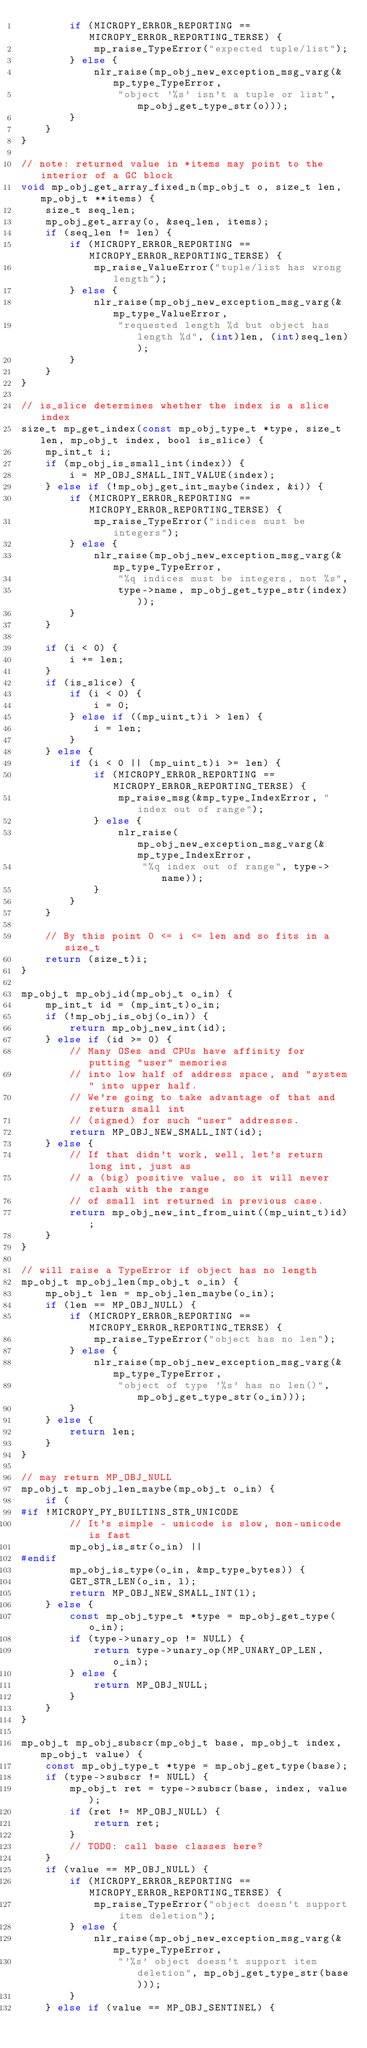Convert code to text. <code><loc_0><loc_0><loc_500><loc_500><_C_>        if (MICROPY_ERROR_REPORTING == MICROPY_ERROR_REPORTING_TERSE) {
            mp_raise_TypeError("expected tuple/list");
        } else {
            nlr_raise(mp_obj_new_exception_msg_varg(&mp_type_TypeError,
                "object '%s' isn't a tuple or list", mp_obj_get_type_str(o)));
        }
    }
}

// note: returned value in *items may point to the interior of a GC block
void mp_obj_get_array_fixed_n(mp_obj_t o, size_t len, mp_obj_t **items) {
    size_t seq_len;
    mp_obj_get_array(o, &seq_len, items);
    if (seq_len != len) {
        if (MICROPY_ERROR_REPORTING == MICROPY_ERROR_REPORTING_TERSE) {
            mp_raise_ValueError("tuple/list has wrong length");
        } else {
            nlr_raise(mp_obj_new_exception_msg_varg(&mp_type_ValueError,
                "requested length %d but object has length %d", (int)len, (int)seq_len));
        }
    }
}

// is_slice determines whether the index is a slice index
size_t mp_get_index(const mp_obj_type_t *type, size_t len, mp_obj_t index, bool is_slice) {
    mp_int_t i;
    if (mp_obj_is_small_int(index)) {
        i = MP_OBJ_SMALL_INT_VALUE(index);
    } else if (!mp_obj_get_int_maybe(index, &i)) {
        if (MICROPY_ERROR_REPORTING == MICROPY_ERROR_REPORTING_TERSE) {
            mp_raise_TypeError("indices must be integers");
        } else {
            nlr_raise(mp_obj_new_exception_msg_varg(&mp_type_TypeError,
                "%q indices must be integers, not %s",
                type->name, mp_obj_get_type_str(index)));
        }
    }

    if (i < 0) {
        i += len;
    }
    if (is_slice) {
        if (i < 0) {
            i = 0;
        } else if ((mp_uint_t)i > len) {
            i = len;
        }
    } else {
        if (i < 0 || (mp_uint_t)i >= len) {
            if (MICROPY_ERROR_REPORTING == MICROPY_ERROR_REPORTING_TERSE) {
                mp_raise_msg(&mp_type_IndexError, "index out of range");
            } else {
                nlr_raise(mp_obj_new_exception_msg_varg(&mp_type_IndexError,
                    "%q index out of range", type->name));
            }
        }
    }

    // By this point 0 <= i <= len and so fits in a size_t
    return (size_t)i;
}

mp_obj_t mp_obj_id(mp_obj_t o_in) {
    mp_int_t id = (mp_int_t)o_in;
    if (!mp_obj_is_obj(o_in)) {
        return mp_obj_new_int(id);
    } else if (id >= 0) {
        // Many OSes and CPUs have affinity for putting "user" memories
        // into low half of address space, and "system" into upper half.
        // We're going to take advantage of that and return small int
        // (signed) for such "user" addresses.
        return MP_OBJ_NEW_SMALL_INT(id);
    } else {
        // If that didn't work, well, let's return long int, just as
        // a (big) positive value, so it will never clash with the range
        // of small int returned in previous case.
        return mp_obj_new_int_from_uint((mp_uint_t)id);
    }
}

// will raise a TypeError if object has no length
mp_obj_t mp_obj_len(mp_obj_t o_in) {
    mp_obj_t len = mp_obj_len_maybe(o_in);
    if (len == MP_OBJ_NULL) {
        if (MICROPY_ERROR_REPORTING == MICROPY_ERROR_REPORTING_TERSE) {
            mp_raise_TypeError("object has no len");
        } else {
            nlr_raise(mp_obj_new_exception_msg_varg(&mp_type_TypeError,
                "object of type '%s' has no len()", mp_obj_get_type_str(o_in)));
        }
    } else {
        return len;
    }
}

// may return MP_OBJ_NULL
mp_obj_t mp_obj_len_maybe(mp_obj_t o_in) {
    if (
#if !MICROPY_PY_BUILTINS_STR_UNICODE
        // It's simple - unicode is slow, non-unicode is fast
        mp_obj_is_str(o_in) ||
#endif
        mp_obj_is_type(o_in, &mp_type_bytes)) {
        GET_STR_LEN(o_in, l);
        return MP_OBJ_NEW_SMALL_INT(l);
    } else {
        const mp_obj_type_t *type = mp_obj_get_type(o_in);
        if (type->unary_op != NULL) {
            return type->unary_op(MP_UNARY_OP_LEN, o_in);
        } else {
            return MP_OBJ_NULL;
        }
    }
}

mp_obj_t mp_obj_subscr(mp_obj_t base, mp_obj_t index, mp_obj_t value) {
    const mp_obj_type_t *type = mp_obj_get_type(base);
    if (type->subscr != NULL) {
        mp_obj_t ret = type->subscr(base, index, value);
        if (ret != MP_OBJ_NULL) {
            return ret;
        }
        // TODO: call base classes here?
    }
    if (value == MP_OBJ_NULL) {
        if (MICROPY_ERROR_REPORTING == MICROPY_ERROR_REPORTING_TERSE) {
            mp_raise_TypeError("object doesn't support item deletion");
        } else {
            nlr_raise(mp_obj_new_exception_msg_varg(&mp_type_TypeError,
                "'%s' object doesn't support item deletion", mp_obj_get_type_str(base)));
        }
    } else if (value == MP_OBJ_SENTINEL) {</code> 